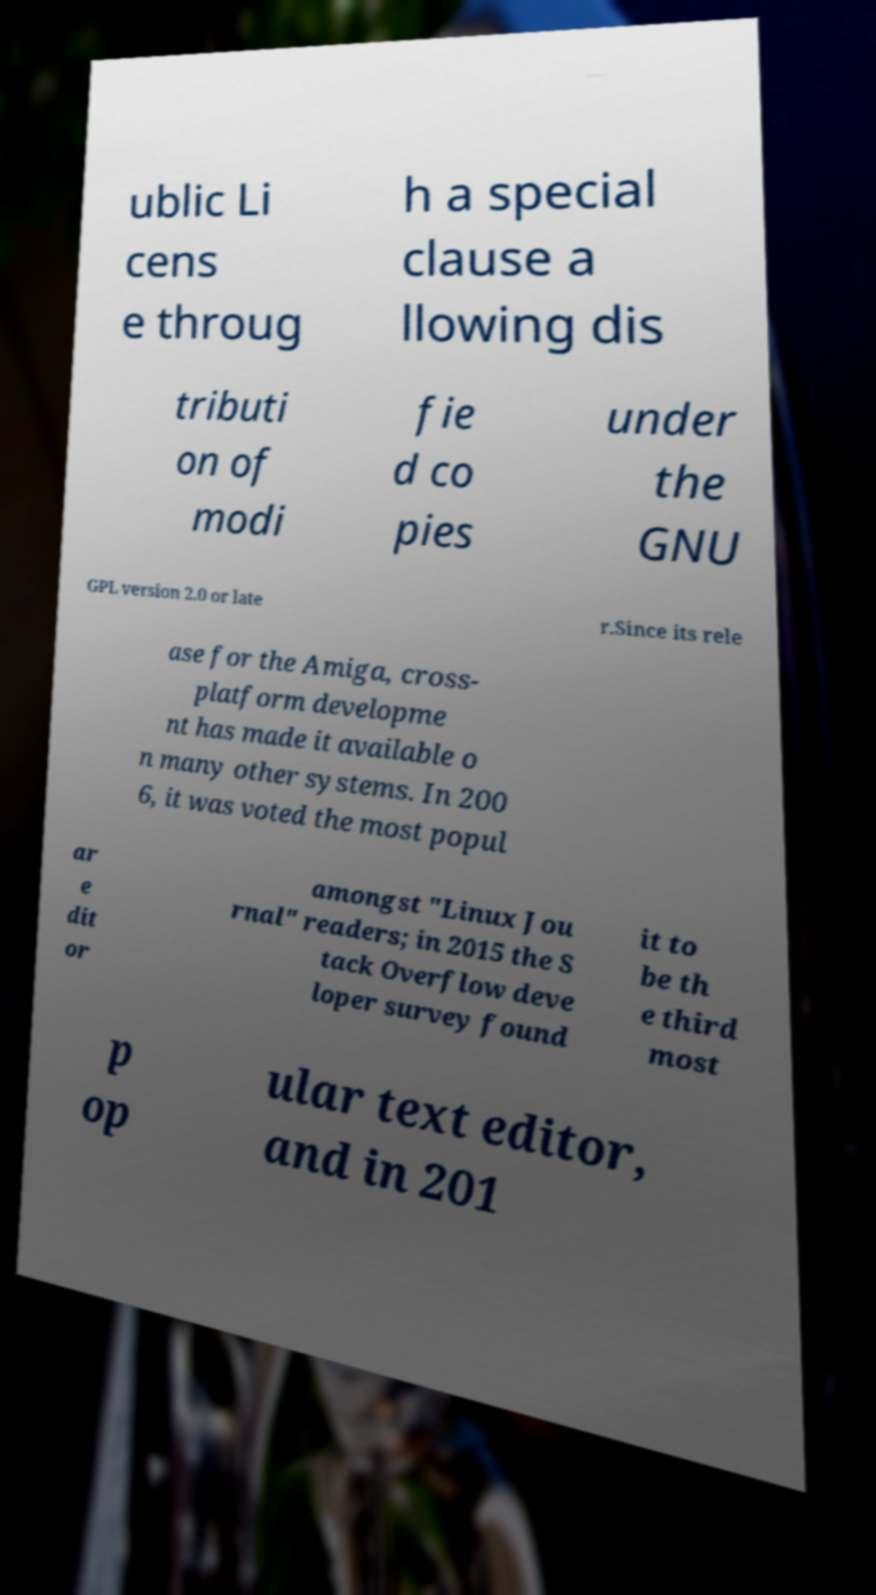There's text embedded in this image that I need extracted. Can you transcribe it verbatim? ublic Li cens e throug h a special clause a llowing dis tributi on of modi fie d co pies under the GNU GPL version 2.0 or late r.Since its rele ase for the Amiga, cross- platform developme nt has made it available o n many other systems. In 200 6, it was voted the most popul ar e dit or amongst "Linux Jou rnal" readers; in 2015 the S tack Overflow deve loper survey found it to be th e third most p op ular text editor, and in 201 